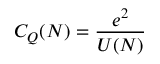Convert formula to latex. <formula><loc_0><loc_0><loc_500><loc_500>C _ { Q } ( N ) = { \frac { e ^ { 2 } } { U ( N ) } }</formula> 